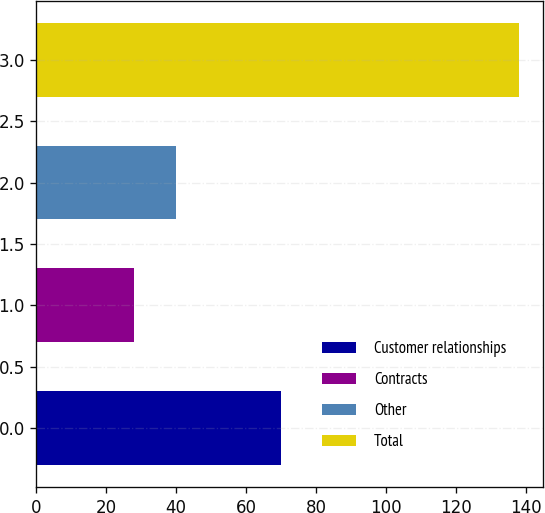Convert chart. <chart><loc_0><loc_0><loc_500><loc_500><bar_chart><fcel>Customer relationships<fcel>Contracts<fcel>Other<fcel>Total<nl><fcel>70<fcel>28<fcel>40<fcel>138<nl></chart> 